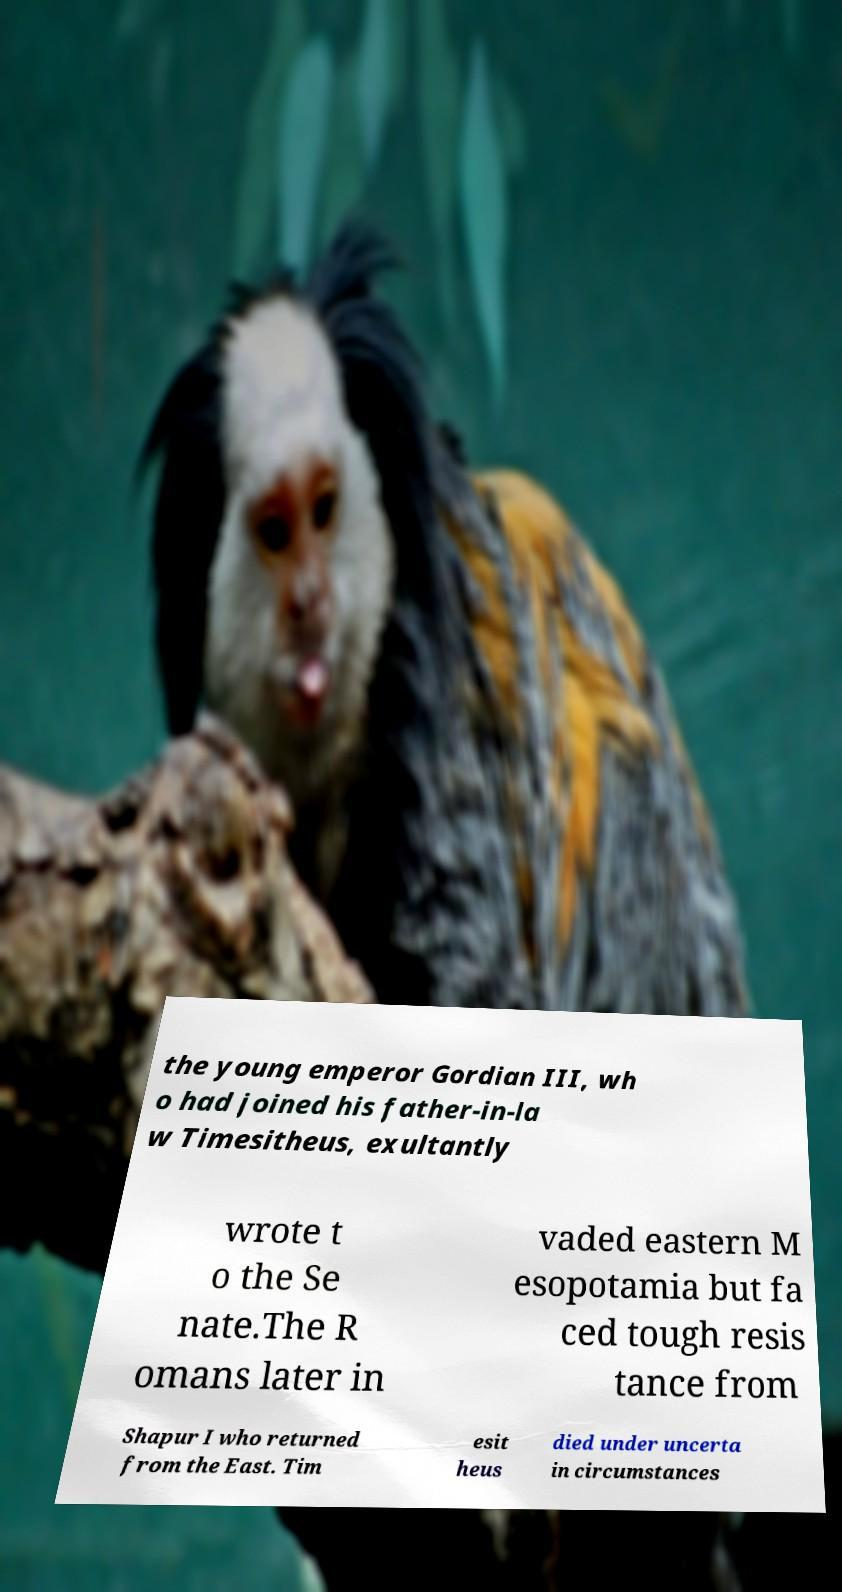Please identify and transcribe the text found in this image. the young emperor Gordian III, wh o had joined his father-in-la w Timesitheus, exultantly wrote t o the Se nate.The R omans later in vaded eastern M esopotamia but fa ced tough resis tance from Shapur I who returned from the East. Tim esit heus died under uncerta in circumstances 